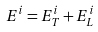Convert formula to latex. <formula><loc_0><loc_0><loc_500><loc_500>E ^ { i } = E ^ { i } _ { T } + E ^ { i } _ { L }</formula> 